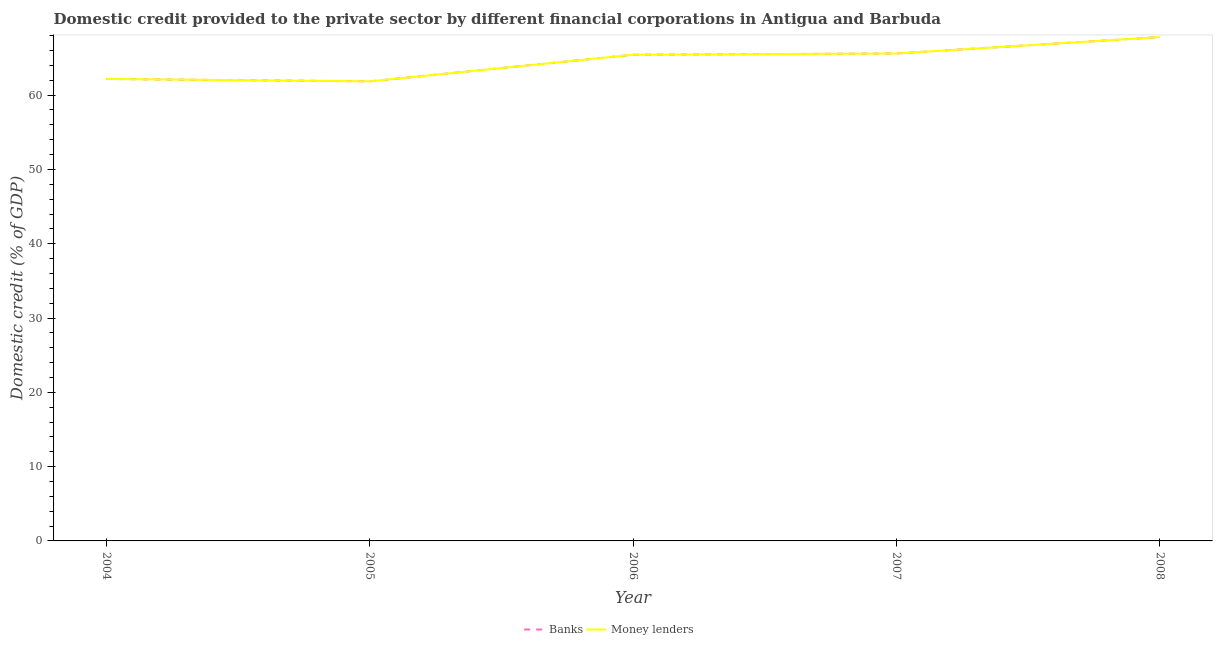How many different coloured lines are there?
Offer a terse response. 2. Does the line corresponding to domestic credit provided by money lenders intersect with the line corresponding to domestic credit provided by banks?
Make the answer very short. Yes. What is the domestic credit provided by money lenders in 2007?
Your answer should be very brief. 65.61. Across all years, what is the maximum domestic credit provided by money lenders?
Your answer should be compact. 67.81. Across all years, what is the minimum domestic credit provided by banks?
Your response must be concise. 61.85. What is the total domestic credit provided by money lenders in the graph?
Offer a very short reply. 322.88. What is the difference between the domestic credit provided by banks in 2004 and that in 2005?
Offer a very short reply. 0.32. What is the difference between the domestic credit provided by money lenders in 2006 and the domestic credit provided by banks in 2004?
Keep it short and to the point. 3.26. What is the average domestic credit provided by banks per year?
Your answer should be very brief. 64.58. In the year 2006, what is the difference between the domestic credit provided by banks and domestic credit provided by money lenders?
Provide a short and direct response. 0. What is the ratio of the domestic credit provided by money lenders in 2006 to that in 2008?
Give a very brief answer. 0.96. What is the difference between the highest and the second highest domestic credit provided by money lenders?
Your answer should be compact. 2.2. What is the difference between the highest and the lowest domestic credit provided by banks?
Your answer should be very brief. 5.96. Is the sum of the domestic credit provided by banks in 2005 and 2008 greater than the maximum domestic credit provided by money lenders across all years?
Offer a terse response. Yes. Is the domestic credit provided by banks strictly greater than the domestic credit provided by money lenders over the years?
Offer a very short reply. No. What is the difference between two consecutive major ticks on the Y-axis?
Offer a very short reply. 10. Are the values on the major ticks of Y-axis written in scientific E-notation?
Your answer should be compact. No. Where does the legend appear in the graph?
Give a very brief answer. Bottom center. How many legend labels are there?
Offer a terse response. 2. What is the title of the graph?
Your answer should be compact. Domestic credit provided to the private sector by different financial corporations in Antigua and Barbuda. What is the label or title of the X-axis?
Ensure brevity in your answer.  Year. What is the label or title of the Y-axis?
Provide a short and direct response. Domestic credit (% of GDP). What is the Domestic credit (% of GDP) of Banks in 2004?
Provide a succinct answer. 62.18. What is the Domestic credit (% of GDP) of Money lenders in 2004?
Give a very brief answer. 62.18. What is the Domestic credit (% of GDP) in Banks in 2005?
Your answer should be compact. 61.85. What is the Domestic credit (% of GDP) in Money lenders in 2005?
Make the answer very short. 61.85. What is the Domestic credit (% of GDP) in Banks in 2006?
Keep it short and to the point. 65.43. What is the Domestic credit (% of GDP) of Money lenders in 2006?
Ensure brevity in your answer.  65.43. What is the Domestic credit (% of GDP) of Banks in 2007?
Your answer should be compact. 65.61. What is the Domestic credit (% of GDP) of Money lenders in 2007?
Offer a terse response. 65.61. What is the Domestic credit (% of GDP) in Banks in 2008?
Provide a succinct answer. 67.81. What is the Domestic credit (% of GDP) in Money lenders in 2008?
Your response must be concise. 67.81. Across all years, what is the maximum Domestic credit (% of GDP) of Banks?
Offer a terse response. 67.81. Across all years, what is the maximum Domestic credit (% of GDP) in Money lenders?
Your answer should be very brief. 67.81. Across all years, what is the minimum Domestic credit (% of GDP) of Banks?
Offer a terse response. 61.85. Across all years, what is the minimum Domestic credit (% of GDP) in Money lenders?
Your answer should be very brief. 61.85. What is the total Domestic credit (% of GDP) in Banks in the graph?
Make the answer very short. 322.88. What is the total Domestic credit (% of GDP) in Money lenders in the graph?
Your answer should be compact. 322.88. What is the difference between the Domestic credit (% of GDP) of Banks in 2004 and that in 2005?
Your answer should be very brief. 0.32. What is the difference between the Domestic credit (% of GDP) in Money lenders in 2004 and that in 2005?
Provide a succinct answer. 0.32. What is the difference between the Domestic credit (% of GDP) in Banks in 2004 and that in 2006?
Keep it short and to the point. -3.26. What is the difference between the Domestic credit (% of GDP) in Money lenders in 2004 and that in 2006?
Provide a short and direct response. -3.26. What is the difference between the Domestic credit (% of GDP) of Banks in 2004 and that in 2007?
Provide a short and direct response. -3.43. What is the difference between the Domestic credit (% of GDP) in Money lenders in 2004 and that in 2007?
Offer a very short reply. -3.43. What is the difference between the Domestic credit (% of GDP) in Banks in 2004 and that in 2008?
Make the answer very short. -5.63. What is the difference between the Domestic credit (% of GDP) in Money lenders in 2004 and that in 2008?
Provide a succinct answer. -5.63. What is the difference between the Domestic credit (% of GDP) in Banks in 2005 and that in 2006?
Your answer should be very brief. -3.58. What is the difference between the Domestic credit (% of GDP) in Money lenders in 2005 and that in 2006?
Give a very brief answer. -3.58. What is the difference between the Domestic credit (% of GDP) in Banks in 2005 and that in 2007?
Keep it short and to the point. -3.75. What is the difference between the Domestic credit (% of GDP) in Money lenders in 2005 and that in 2007?
Offer a terse response. -3.75. What is the difference between the Domestic credit (% of GDP) of Banks in 2005 and that in 2008?
Offer a terse response. -5.96. What is the difference between the Domestic credit (% of GDP) in Money lenders in 2005 and that in 2008?
Your answer should be compact. -5.96. What is the difference between the Domestic credit (% of GDP) of Banks in 2006 and that in 2007?
Offer a very short reply. -0.17. What is the difference between the Domestic credit (% of GDP) of Money lenders in 2006 and that in 2007?
Offer a terse response. -0.17. What is the difference between the Domestic credit (% of GDP) of Banks in 2006 and that in 2008?
Make the answer very short. -2.38. What is the difference between the Domestic credit (% of GDP) in Money lenders in 2006 and that in 2008?
Your response must be concise. -2.38. What is the difference between the Domestic credit (% of GDP) of Banks in 2007 and that in 2008?
Ensure brevity in your answer.  -2.2. What is the difference between the Domestic credit (% of GDP) of Money lenders in 2007 and that in 2008?
Make the answer very short. -2.2. What is the difference between the Domestic credit (% of GDP) of Banks in 2004 and the Domestic credit (% of GDP) of Money lenders in 2005?
Offer a terse response. 0.32. What is the difference between the Domestic credit (% of GDP) of Banks in 2004 and the Domestic credit (% of GDP) of Money lenders in 2006?
Provide a short and direct response. -3.26. What is the difference between the Domestic credit (% of GDP) of Banks in 2004 and the Domestic credit (% of GDP) of Money lenders in 2007?
Offer a very short reply. -3.43. What is the difference between the Domestic credit (% of GDP) in Banks in 2004 and the Domestic credit (% of GDP) in Money lenders in 2008?
Your answer should be very brief. -5.63. What is the difference between the Domestic credit (% of GDP) in Banks in 2005 and the Domestic credit (% of GDP) in Money lenders in 2006?
Offer a very short reply. -3.58. What is the difference between the Domestic credit (% of GDP) of Banks in 2005 and the Domestic credit (% of GDP) of Money lenders in 2007?
Offer a terse response. -3.75. What is the difference between the Domestic credit (% of GDP) in Banks in 2005 and the Domestic credit (% of GDP) in Money lenders in 2008?
Your answer should be very brief. -5.96. What is the difference between the Domestic credit (% of GDP) of Banks in 2006 and the Domestic credit (% of GDP) of Money lenders in 2007?
Make the answer very short. -0.17. What is the difference between the Domestic credit (% of GDP) of Banks in 2006 and the Domestic credit (% of GDP) of Money lenders in 2008?
Ensure brevity in your answer.  -2.38. What is the difference between the Domestic credit (% of GDP) of Banks in 2007 and the Domestic credit (% of GDP) of Money lenders in 2008?
Keep it short and to the point. -2.2. What is the average Domestic credit (% of GDP) of Banks per year?
Provide a short and direct response. 64.58. What is the average Domestic credit (% of GDP) of Money lenders per year?
Make the answer very short. 64.58. In the year 2005, what is the difference between the Domestic credit (% of GDP) in Banks and Domestic credit (% of GDP) in Money lenders?
Your answer should be very brief. 0. In the year 2006, what is the difference between the Domestic credit (% of GDP) in Banks and Domestic credit (% of GDP) in Money lenders?
Ensure brevity in your answer.  0. In the year 2007, what is the difference between the Domestic credit (% of GDP) of Banks and Domestic credit (% of GDP) of Money lenders?
Your response must be concise. 0. In the year 2008, what is the difference between the Domestic credit (% of GDP) of Banks and Domestic credit (% of GDP) of Money lenders?
Your answer should be compact. 0. What is the ratio of the Domestic credit (% of GDP) in Banks in 2004 to that in 2006?
Offer a very short reply. 0.95. What is the ratio of the Domestic credit (% of GDP) in Money lenders in 2004 to that in 2006?
Provide a succinct answer. 0.95. What is the ratio of the Domestic credit (% of GDP) in Banks in 2004 to that in 2007?
Your answer should be compact. 0.95. What is the ratio of the Domestic credit (% of GDP) in Money lenders in 2004 to that in 2007?
Your answer should be compact. 0.95. What is the ratio of the Domestic credit (% of GDP) in Banks in 2004 to that in 2008?
Your response must be concise. 0.92. What is the ratio of the Domestic credit (% of GDP) of Money lenders in 2004 to that in 2008?
Keep it short and to the point. 0.92. What is the ratio of the Domestic credit (% of GDP) in Banks in 2005 to that in 2006?
Keep it short and to the point. 0.95. What is the ratio of the Domestic credit (% of GDP) in Money lenders in 2005 to that in 2006?
Make the answer very short. 0.95. What is the ratio of the Domestic credit (% of GDP) in Banks in 2005 to that in 2007?
Offer a very short reply. 0.94. What is the ratio of the Domestic credit (% of GDP) of Money lenders in 2005 to that in 2007?
Ensure brevity in your answer.  0.94. What is the ratio of the Domestic credit (% of GDP) in Banks in 2005 to that in 2008?
Give a very brief answer. 0.91. What is the ratio of the Domestic credit (% of GDP) of Money lenders in 2005 to that in 2008?
Offer a very short reply. 0.91. What is the ratio of the Domestic credit (% of GDP) of Banks in 2006 to that in 2007?
Keep it short and to the point. 1. What is the ratio of the Domestic credit (% of GDP) of Money lenders in 2006 to that in 2007?
Your response must be concise. 1. What is the ratio of the Domestic credit (% of GDP) in Banks in 2006 to that in 2008?
Your response must be concise. 0.96. What is the ratio of the Domestic credit (% of GDP) of Money lenders in 2006 to that in 2008?
Offer a terse response. 0.96. What is the ratio of the Domestic credit (% of GDP) of Banks in 2007 to that in 2008?
Offer a terse response. 0.97. What is the ratio of the Domestic credit (% of GDP) in Money lenders in 2007 to that in 2008?
Offer a very short reply. 0.97. What is the difference between the highest and the second highest Domestic credit (% of GDP) of Banks?
Give a very brief answer. 2.2. What is the difference between the highest and the second highest Domestic credit (% of GDP) in Money lenders?
Provide a succinct answer. 2.2. What is the difference between the highest and the lowest Domestic credit (% of GDP) in Banks?
Give a very brief answer. 5.96. What is the difference between the highest and the lowest Domestic credit (% of GDP) in Money lenders?
Give a very brief answer. 5.96. 